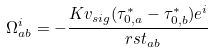Convert formula to latex. <formula><loc_0><loc_0><loc_500><loc_500>\Omega ^ { i } _ { a b } = - \frac { K v _ { s i g } ( \tau _ { 0 , a } ^ { * } - \tau _ { 0 , b } ^ { * } ) e ^ { i } } { \ r s t _ { a b } }</formula> 